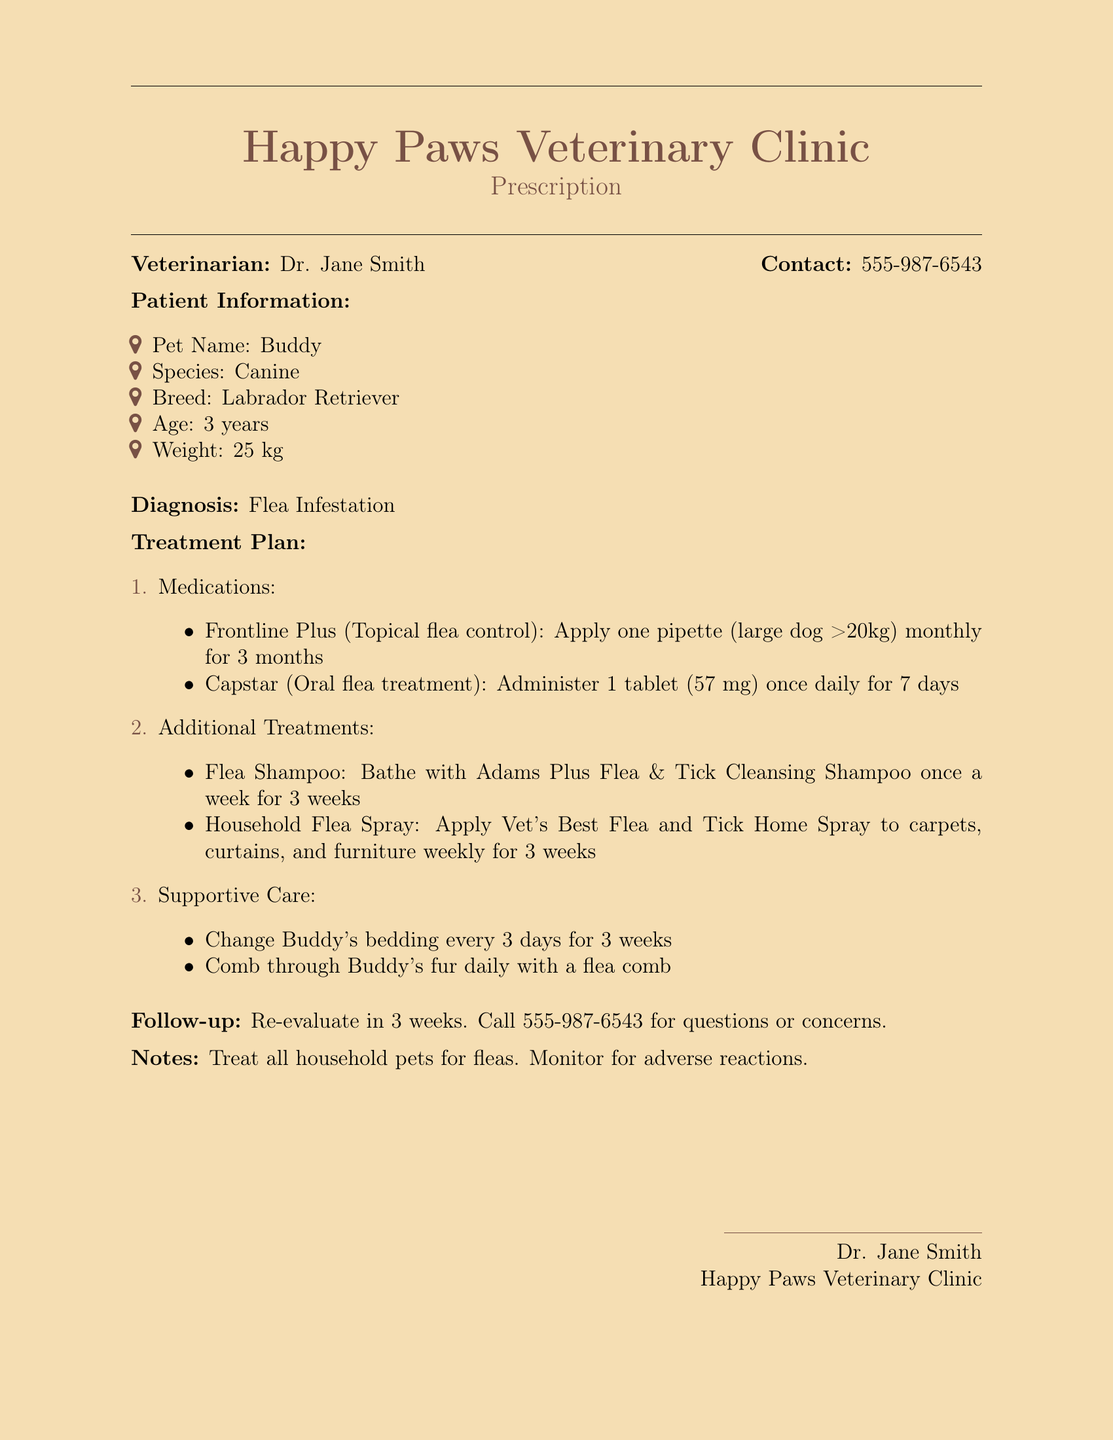What is the patient's name? The patient's name is listed under Patient Information in the document.
Answer: Buddy What is the diagnosis? The diagnosis is mentioned in the document under the Diagnosis section.
Answer: Flea Infestation What medication is recommended for topical flea control? The medication for topical flea control is provided in the Treatment Plan section.
Answer: Frontline Plus How long should Capstar be administered? The document specifies the duration of administering Capstar in the Treatment Plan.
Answer: 7 days How often should Buddy's bedding be changed? The frequency of changing Buddy's bedding is indicated in the Supportive Care section of the Treatment Plan.
Answer: Every 3 days What is the follow-up period? The follow-up period is clearly stated in the Follow-up section of the document.
Answer: 3 weeks What type of shampoo should be used for bathing? The type of shampoo for bathing is mentioned specifically in the Additional Treatments section.
Answer: Adams Plus Flea & Tick Cleansing Shampoo What should be done to carpets and curtains? This action is explicitly listed under Additional Treatments in the document.
Answer: Apply flea spray Who is the veterinarian? The veterinarian's name can be found at the top of the document.
Answer: Dr. Jane Smith 